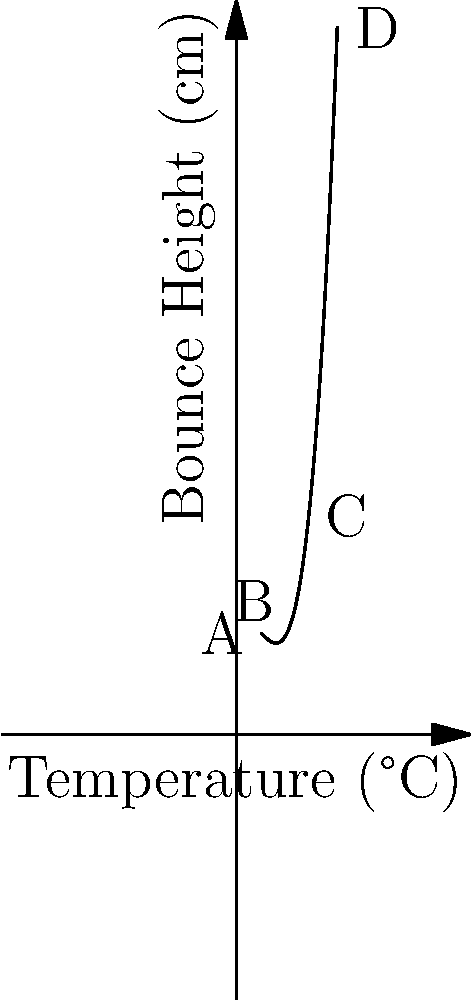As a copious note-taking squash enthusiast, you've been studying the relationship between court temperature and ball bounce height. The cubic function graph above demonstrates this correlation. At which point does the ball reach its maximum bounce height, and what is the approximate temperature at this point? Let's analyze this step-by-step:

1) The graph represents a cubic function of the form $f(x) = ax^3 + bx^2 + cx + d$, where $x$ is the temperature and $f(x)$ is the bounce height.

2) To find the maximum point, we need to identify where the slope of the curve is zero. This occurs at the turning point of the function.

3) Visually inspecting the graph, we can see that the curve reaches its highest point between points B and C.

4) The x-axis represents temperature, ranging from 10°C to 40°C.

5) The turning point appears to be closer to point B than C, approximately at 23-25°C.

6) At this point, the bounce height reaches its maximum before starting to decrease again as temperature continues to increase.

7) This makes sense in the context of squash, as very cold courts (point A) would result in less bounce, while extremely hot courts (point D) might cause the ball to become too soft, also reducing bounce.

8) The point we're looking for is the vertex of the parabola-like section of the cubic function.
Answer: Point B, approximately 23-25°C 